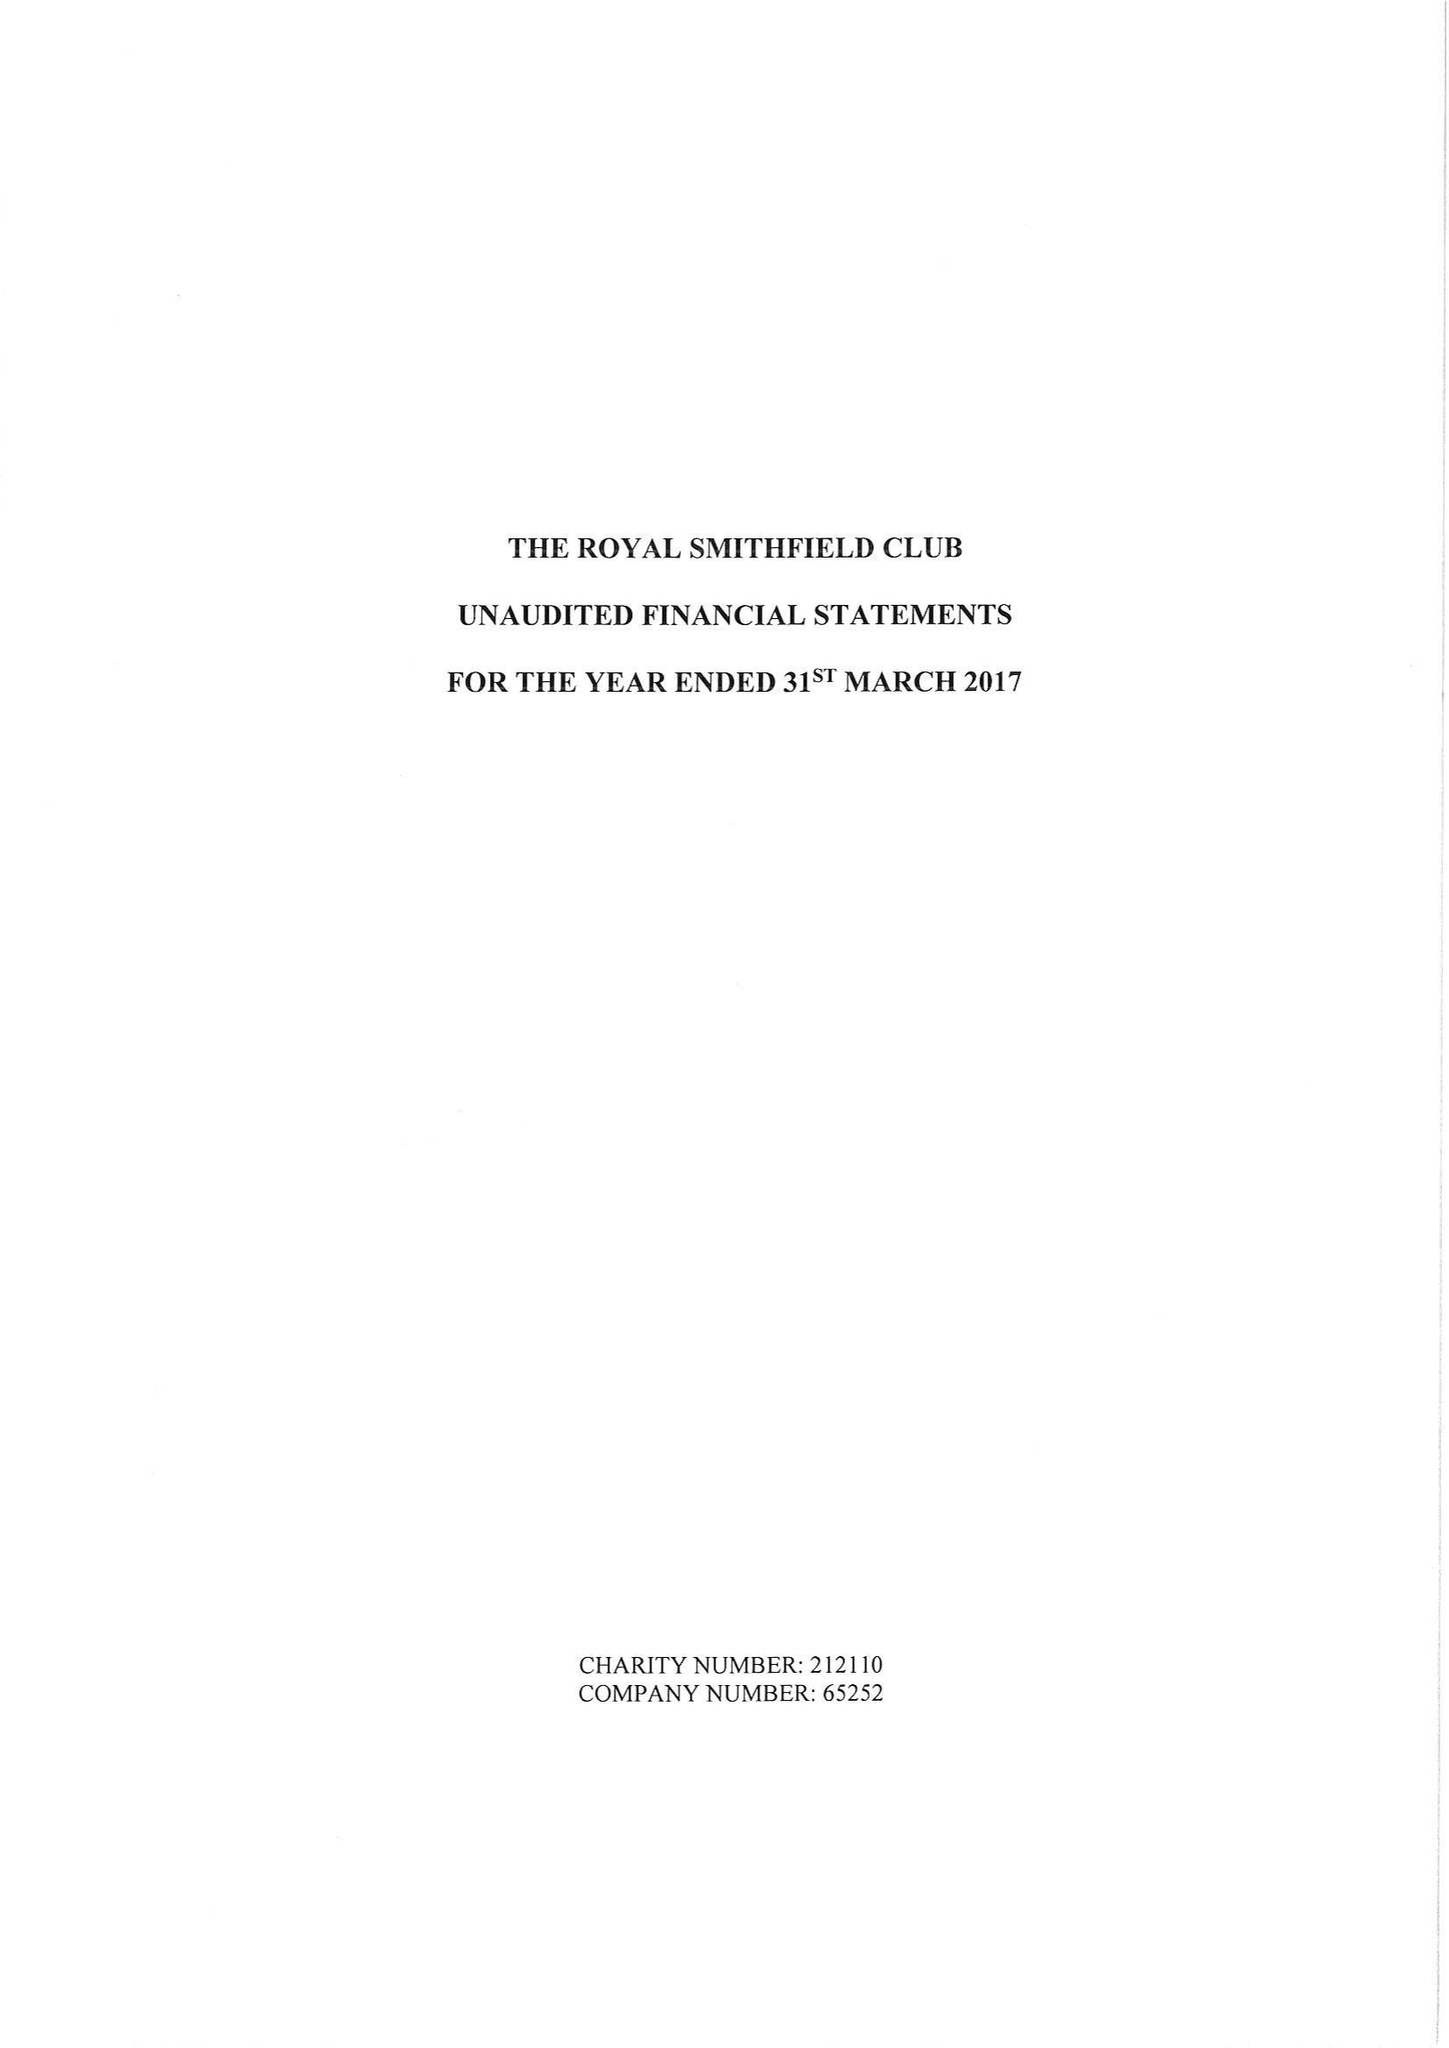What is the value for the spending_annually_in_british_pounds?
Answer the question using a single word or phrase. 31961.00 